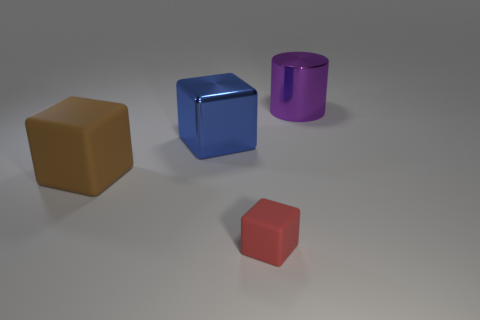What number of large purple metal objects are there?
Provide a short and direct response. 1. What number of blue metallic blocks have the same size as the cylinder?
Give a very brief answer. 1. What is the red object made of?
Make the answer very short. Rubber. Is the color of the large cylinder the same as the cube behind the brown rubber cube?
Offer a terse response. No. Is there anything else that is the same size as the brown thing?
Make the answer very short. Yes. There is a thing that is behind the brown thing and to the left of the purple shiny cylinder; what is its size?
Make the answer very short. Large. What shape is the object that is the same material as the big brown cube?
Offer a terse response. Cube. Are the brown block and the large thing that is to the right of the red matte cube made of the same material?
Offer a terse response. No. Is there a big purple shiny cylinder that is right of the block in front of the brown matte object?
Provide a succinct answer. Yes. There is a blue thing that is the same shape as the large brown thing; what material is it?
Provide a short and direct response. Metal. 